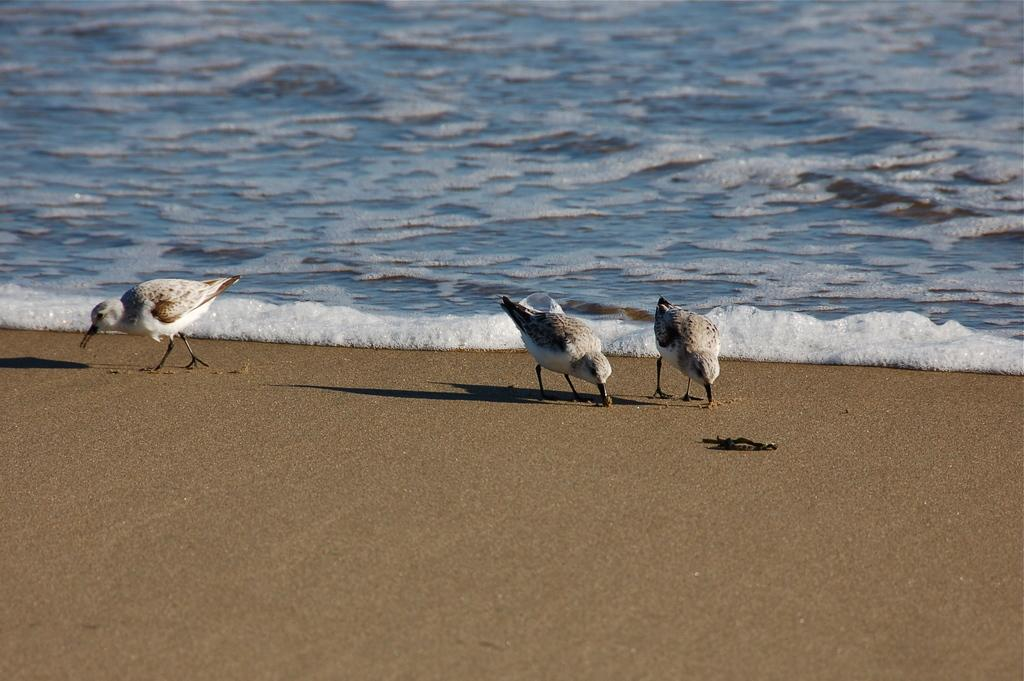How many birds are in the image? There are three birds in the image. What are the birds standing on? The birds are standing on the sand. What is the location of the sand in relation to the sea? The sand is in front of the sea. What type of war is being fought on the sand in the image? There is no war or any indication of conflict in the image; it features three birds standing on the sand. 